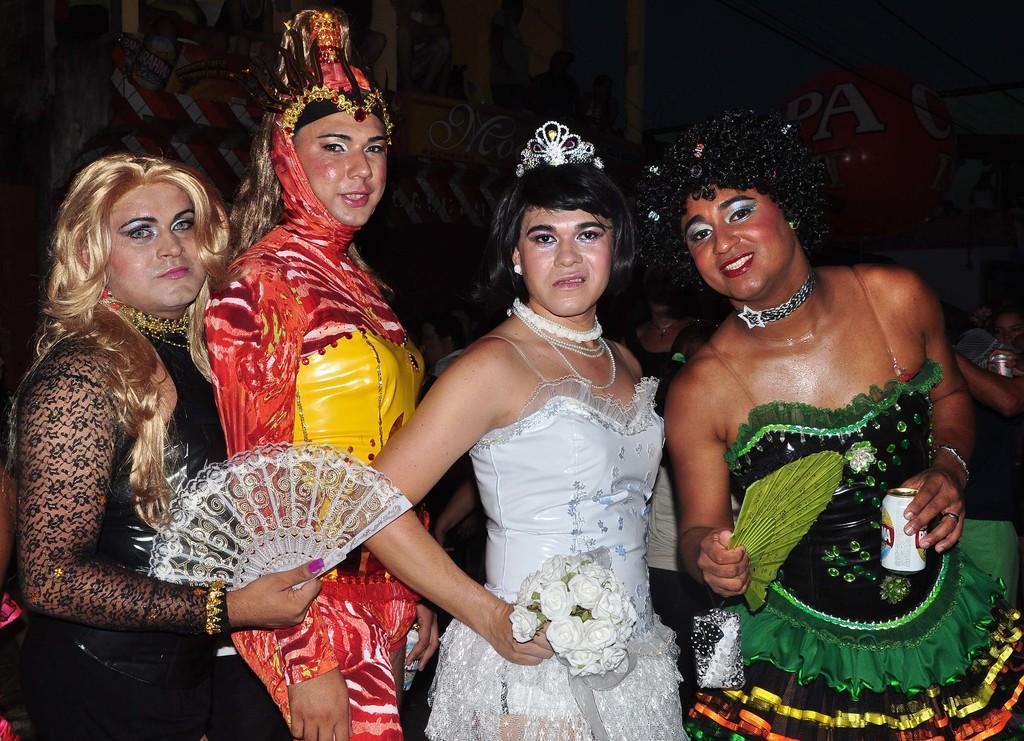How would you summarize this image in a sentence or two? This image is taken indoors. In this image the background is a little dark. There are two boards with text on them. In the middle of the image four women are standing and they are holding a few objects in their hands. 